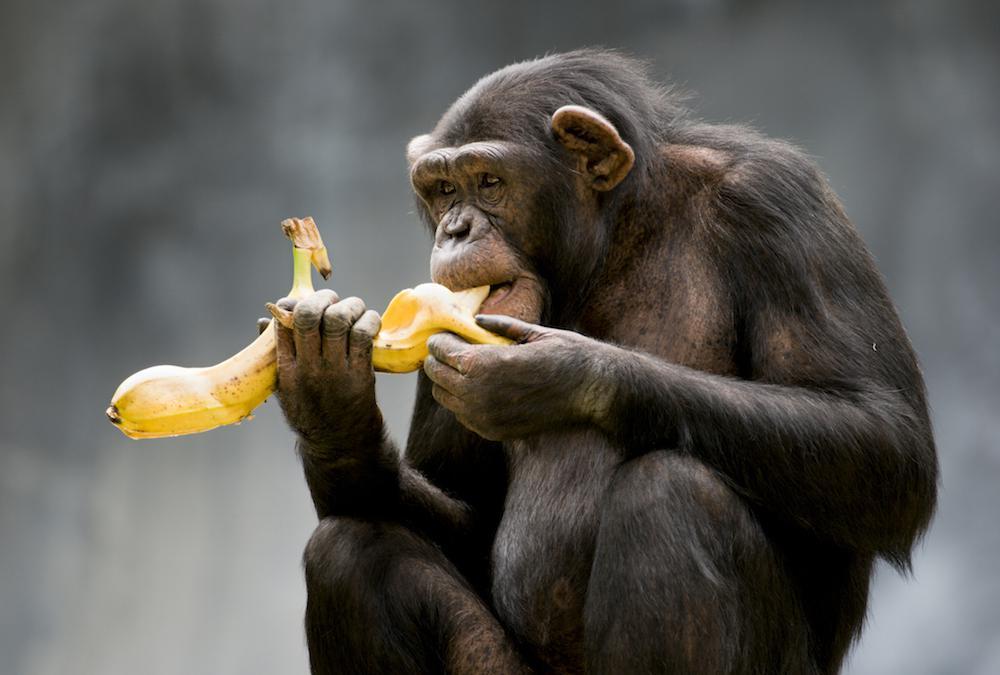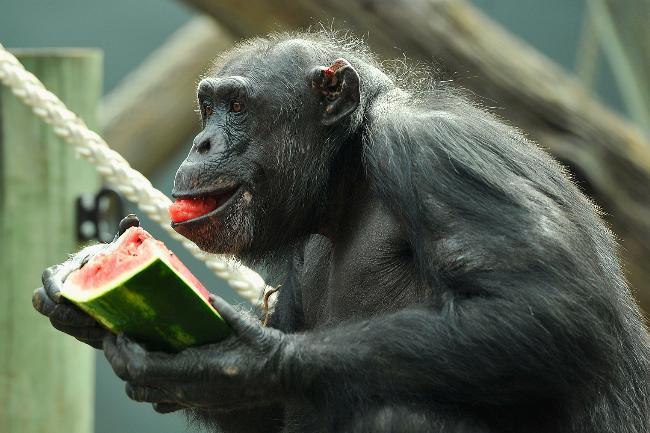The first image is the image on the left, the second image is the image on the right. Considering the images on both sides, is "There is green food in the mouth of the monkey in the image on the right." valid? Answer yes or no. No. The first image is the image on the left, the second image is the image on the right. For the images displayed, is the sentence "There is no more than 4 chimpanzees." factually correct? Answer yes or no. Yes. 